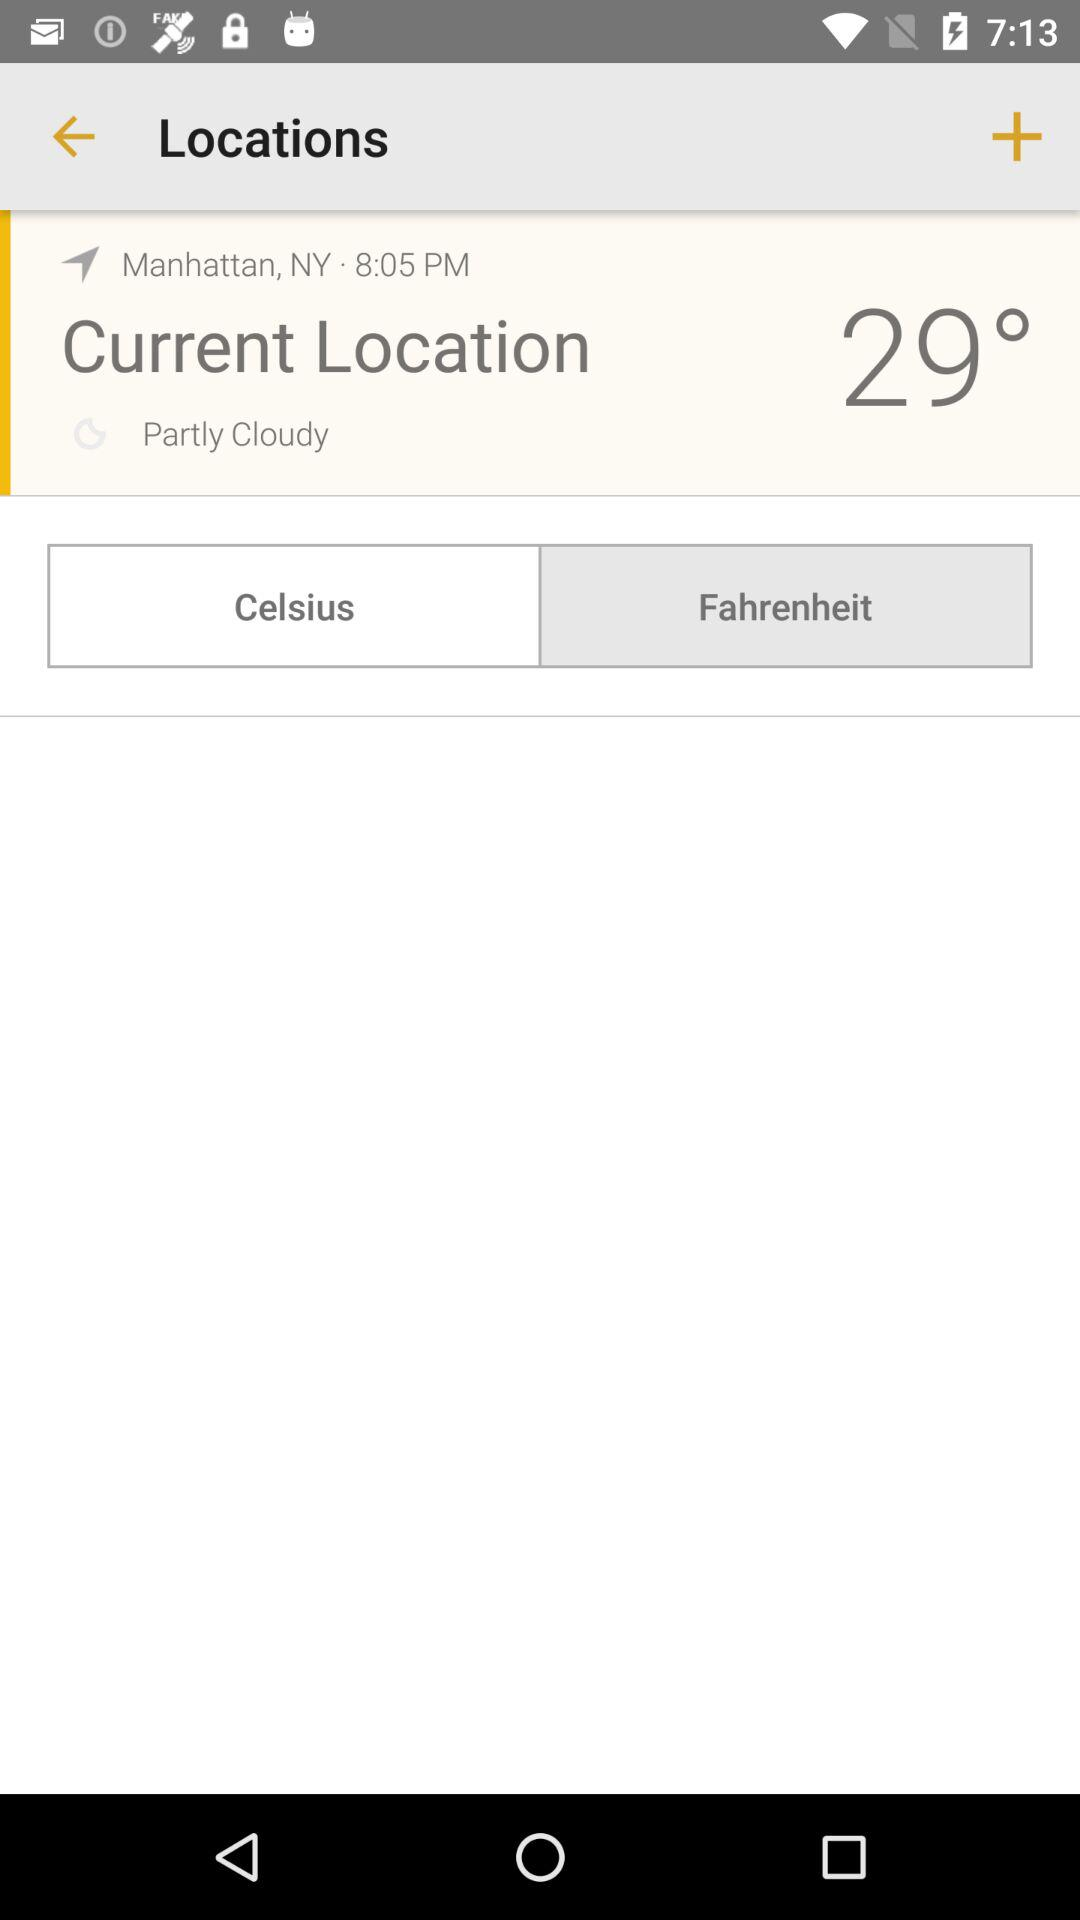What is the temperature at 8:05 PM? The temperature is 29°. 